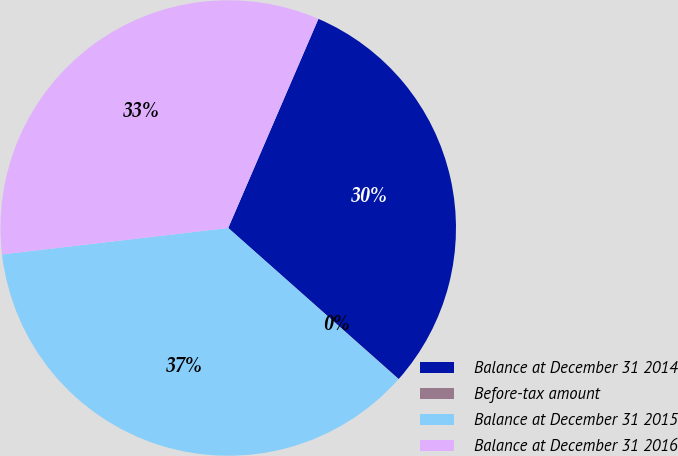<chart> <loc_0><loc_0><loc_500><loc_500><pie_chart><fcel>Balance at December 31 2014<fcel>Before-tax amount<fcel>Balance at December 31 2015<fcel>Balance at December 31 2016<nl><fcel>30.06%<fcel>0.02%<fcel>36.59%<fcel>33.33%<nl></chart> 